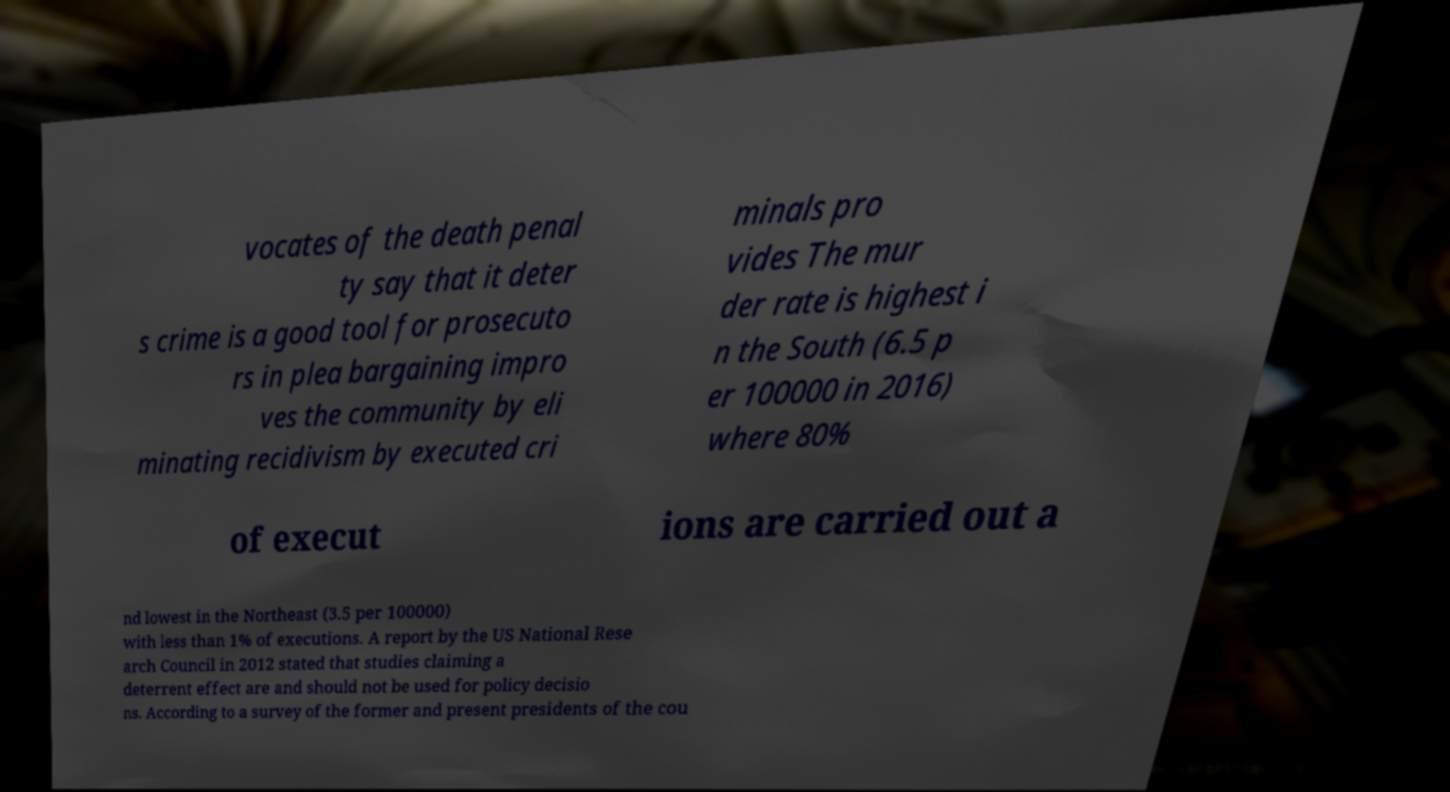Please read and relay the text visible in this image. What does it say? vocates of the death penal ty say that it deter s crime is a good tool for prosecuto rs in plea bargaining impro ves the community by eli minating recidivism by executed cri minals pro vides The mur der rate is highest i n the South (6.5 p er 100000 in 2016) where 80% of execut ions are carried out a nd lowest in the Northeast (3.5 per 100000) with less than 1% of executions. A report by the US National Rese arch Council in 2012 stated that studies claiming a deterrent effect are and should not be used for policy decisio ns. According to a survey of the former and present presidents of the cou 